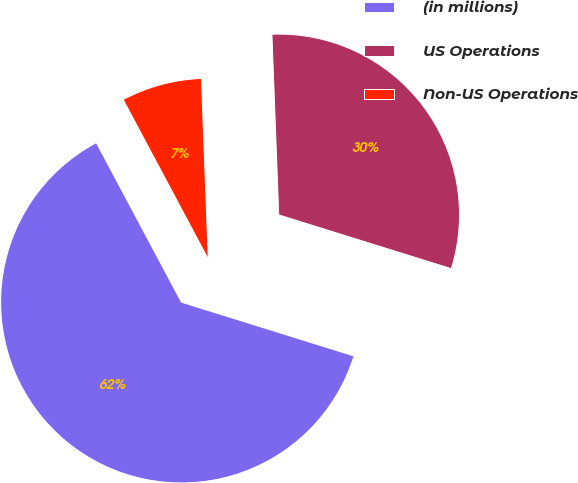<chart> <loc_0><loc_0><loc_500><loc_500><pie_chart><fcel>(in millions)<fcel>US Operations<fcel>Non-US Operations<nl><fcel>62.39%<fcel>30.41%<fcel>7.2%<nl></chart> 